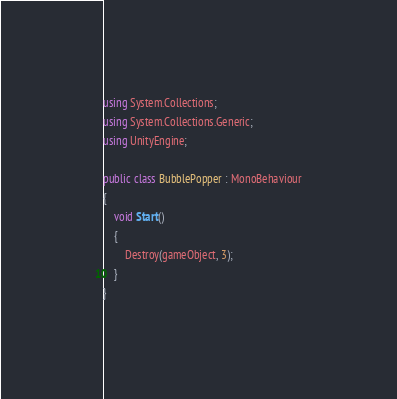Convert code to text. <code><loc_0><loc_0><loc_500><loc_500><_C#_>using System.Collections;
using System.Collections.Generic;
using UnityEngine;

public class BubblePopper : MonoBehaviour
{
    void Start()
    {
        Destroy(gameObject, 3);
    }
}
</code> 